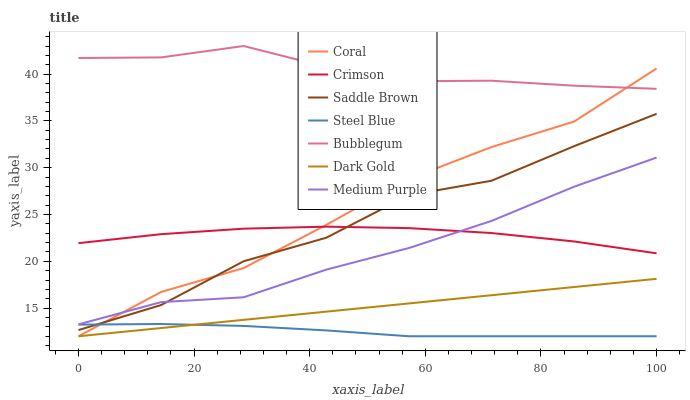Does Steel Blue have the minimum area under the curve?
Answer yes or no. Yes. Does Bubblegum have the maximum area under the curve?
Answer yes or no. Yes. Does Coral have the minimum area under the curve?
Answer yes or no. No. Does Coral have the maximum area under the curve?
Answer yes or no. No. Is Dark Gold the smoothest?
Answer yes or no. Yes. Is Saddle Brown the roughest?
Answer yes or no. Yes. Is Coral the smoothest?
Answer yes or no. No. Is Coral the roughest?
Answer yes or no. No. Does Dark Gold have the lowest value?
Answer yes or no. Yes. Does Bubblegum have the lowest value?
Answer yes or no. No. Does Bubblegum have the highest value?
Answer yes or no. Yes. Does Coral have the highest value?
Answer yes or no. No. Is Steel Blue less than Crimson?
Answer yes or no. Yes. Is Bubblegum greater than Saddle Brown?
Answer yes or no. Yes. Does Saddle Brown intersect Coral?
Answer yes or no. Yes. Is Saddle Brown less than Coral?
Answer yes or no. No. Is Saddle Brown greater than Coral?
Answer yes or no. No. Does Steel Blue intersect Crimson?
Answer yes or no. No. 